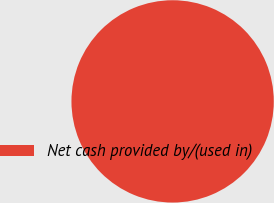Convert chart. <chart><loc_0><loc_0><loc_500><loc_500><pie_chart><fcel>Net cash provided by/(used in)<nl><fcel>100.0%<nl></chart> 